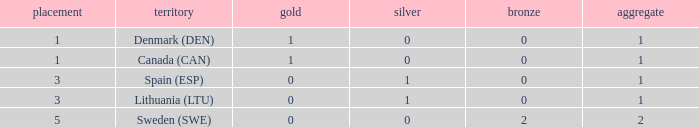What is the rank when there was less than 1 gold, 0 bronze, and more than 1 total? None. 